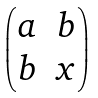<formula> <loc_0><loc_0><loc_500><loc_500>\begin{pmatrix} a & b \\ b & x \end{pmatrix}</formula> 